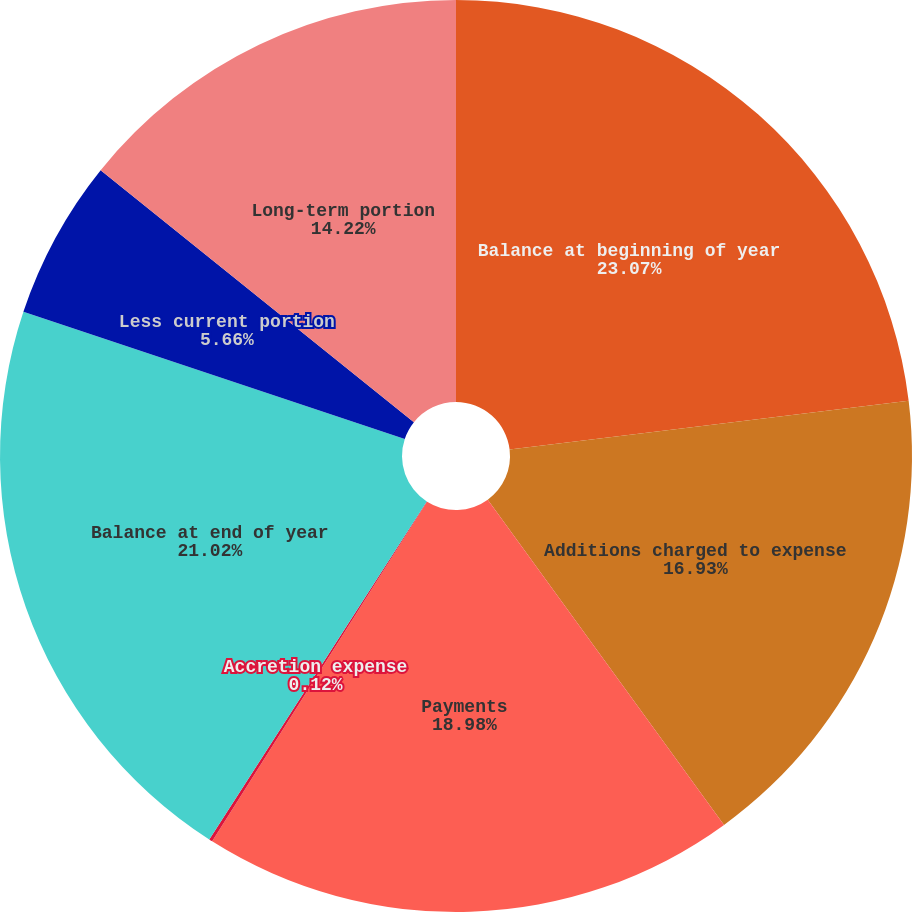Convert chart. <chart><loc_0><loc_0><loc_500><loc_500><pie_chart><fcel>Balance at beginning of year<fcel>Additions charged to expense<fcel>Payments<fcel>Accretion expense<fcel>Balance at end of year<fcel>Less current portion<fcel>Long-term portion<nl><fcel>23.07%<fcel>16.93%<fcel>18.98%<fcel>0.12%<fcel>21.02%<fcel>5.66%<fcel>14.22%<nl></chart> 